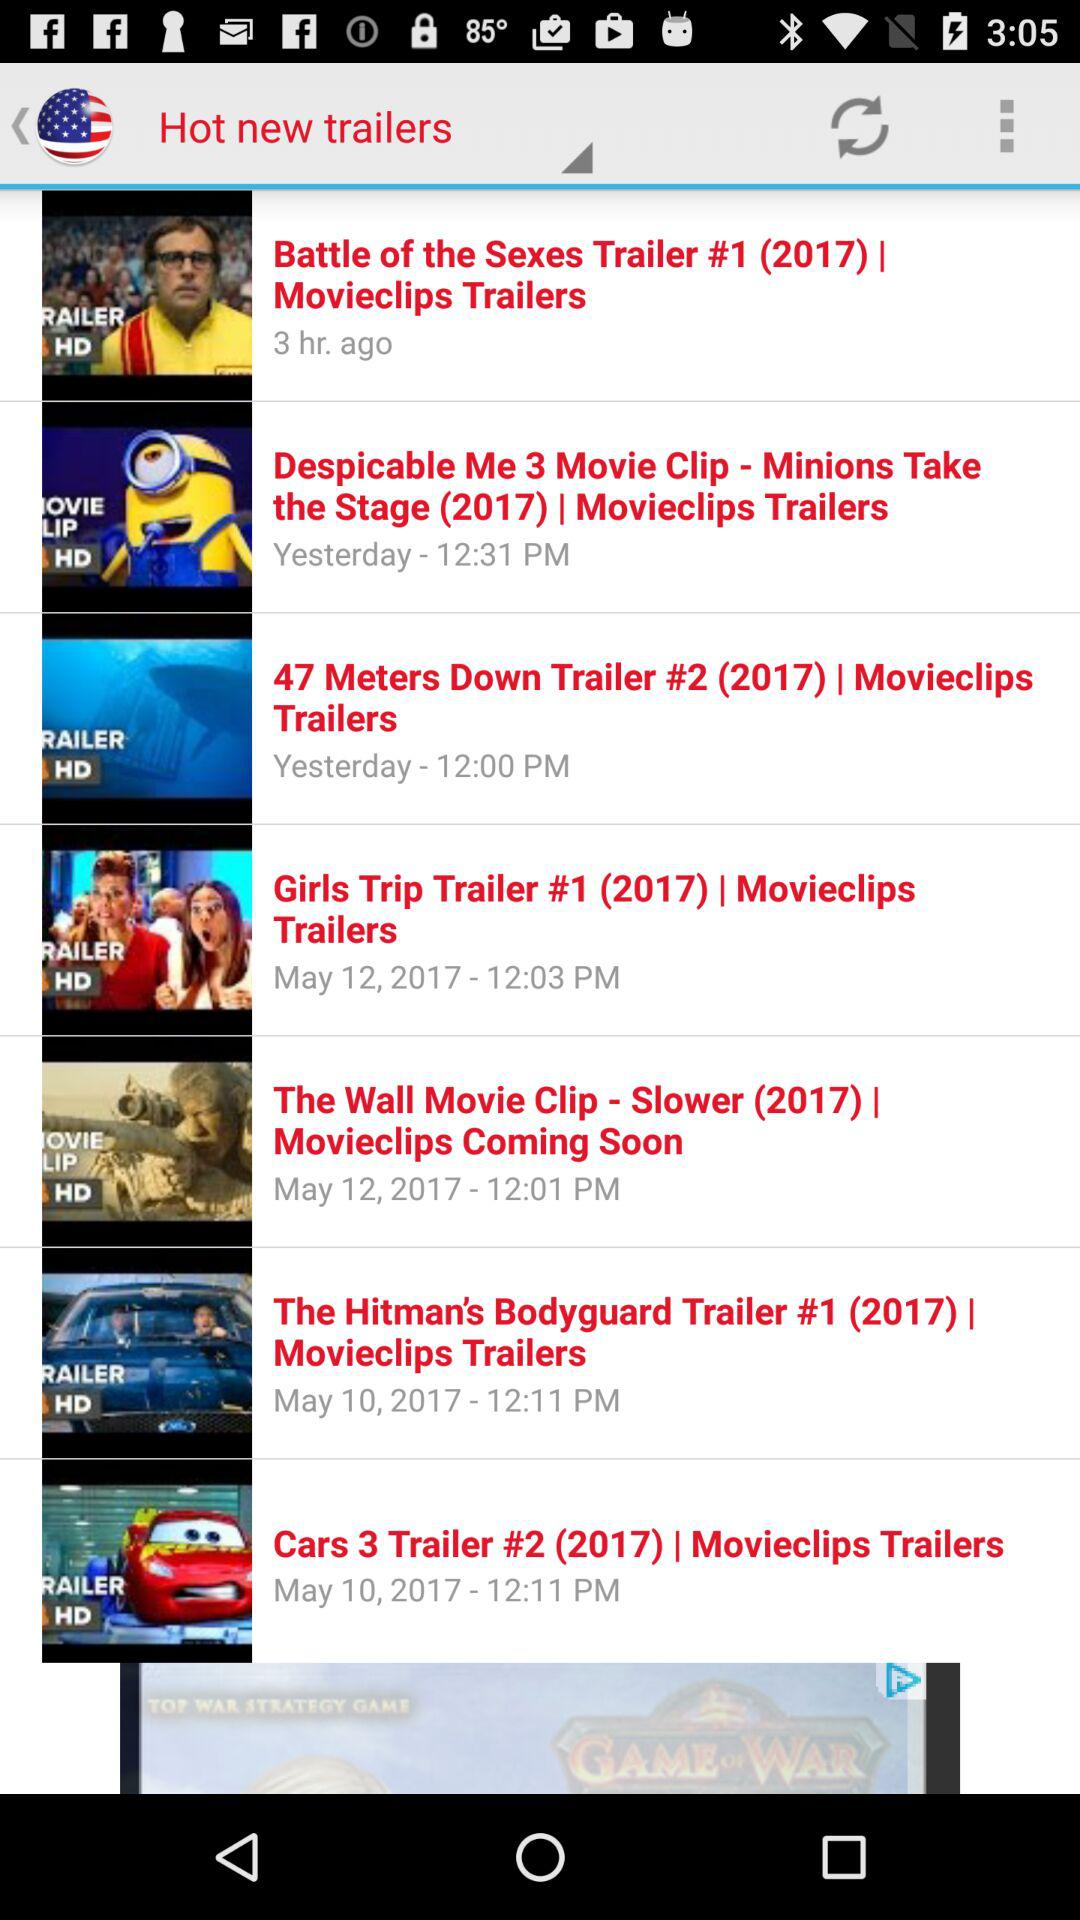What is the time of the "Girls Trip" trailer? The time is 12:03 PM. 